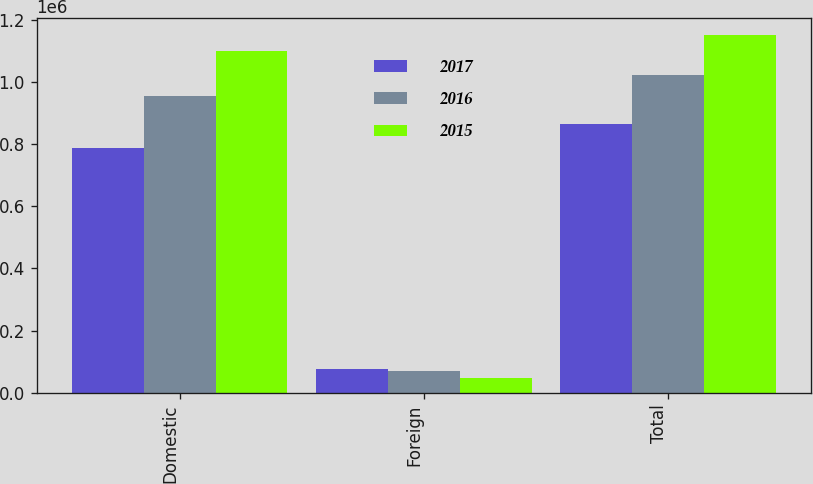<chart> <loc_0><loc_0><loc_500><loc_500><stacked_bar_chart><ecel><fcel>Domestic<fcel>Foreign<fcel>Total<nl><fcel>2017<fcel>788878<fcel>74961<fcel>863839<nl><fcel>2016<fcel>954138<fcel>69773<fcel>1.02391e+06<nl><fcel>2015<fcel>1.10143e+06<fcel>48736<fcel>1.15016e+06<nl></chart> 